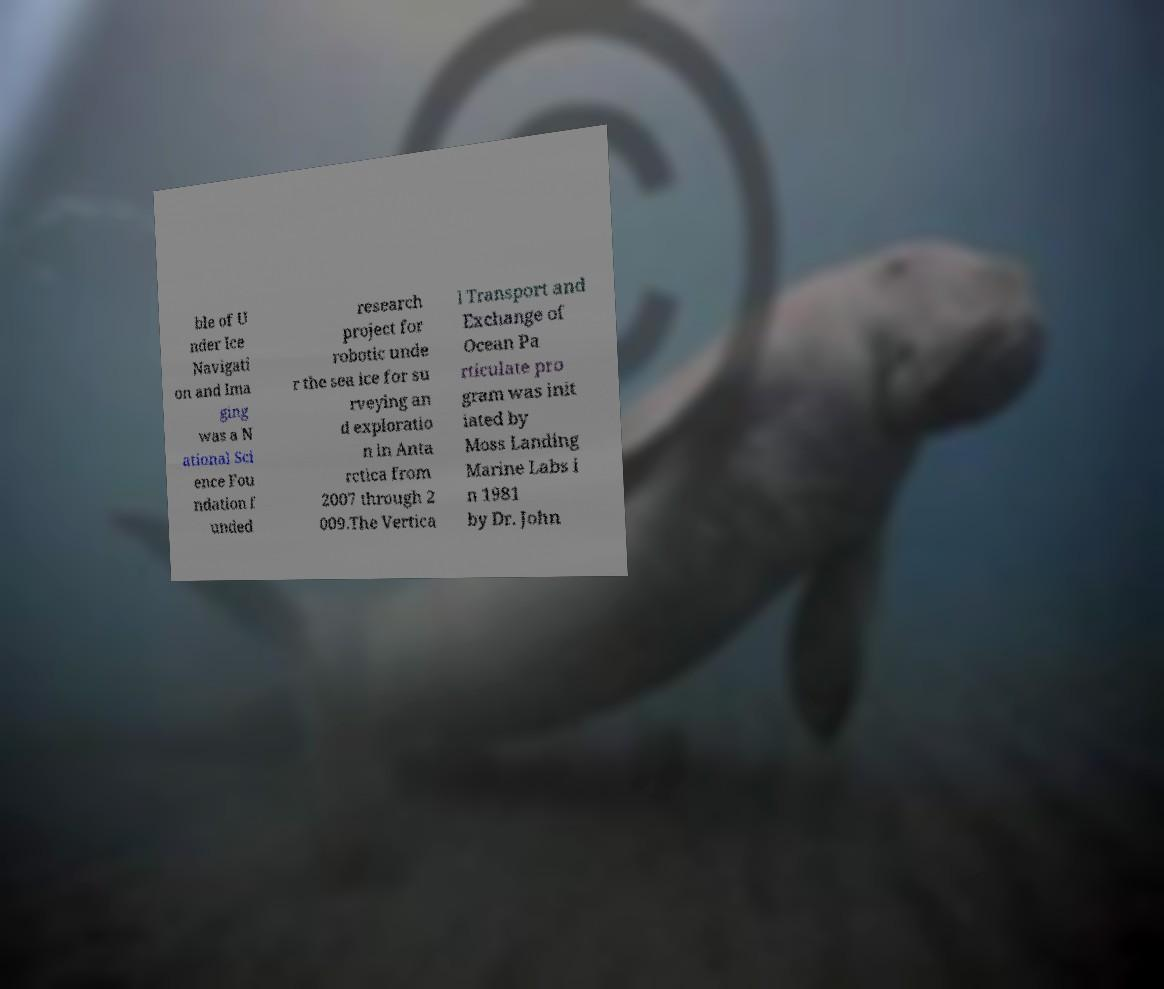Please read and relay the text visible in this image. What does it say? ble of U nder Ice Navigati on and Ima ging was a N ational Sci ence Fou ndation f unded research project for robotic unde r the sea ice for su rveying an d exploratio n in Anta rctica from 2007 through 2 009.The Vertica l Transport and Exchange of Ocean Pa rticulate pro gram was init iated by Moss Landing Marine Labs i n 1981 by Dr. John 